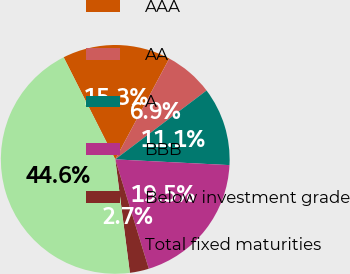<chart> <loc_0><loc_0><loc_500><loc_500><pie_chart><fcel>AAA<fcel>AA<fcel>A<fcel>BBB<fcel>Below investment grade<fcel>Total fixed maturities<nl><fcel>15.27%<fcel>6.89%<fcel>11.08%<fcel>19.46%<fcel>2.7%<fcel>44.59%<nl></chart> 